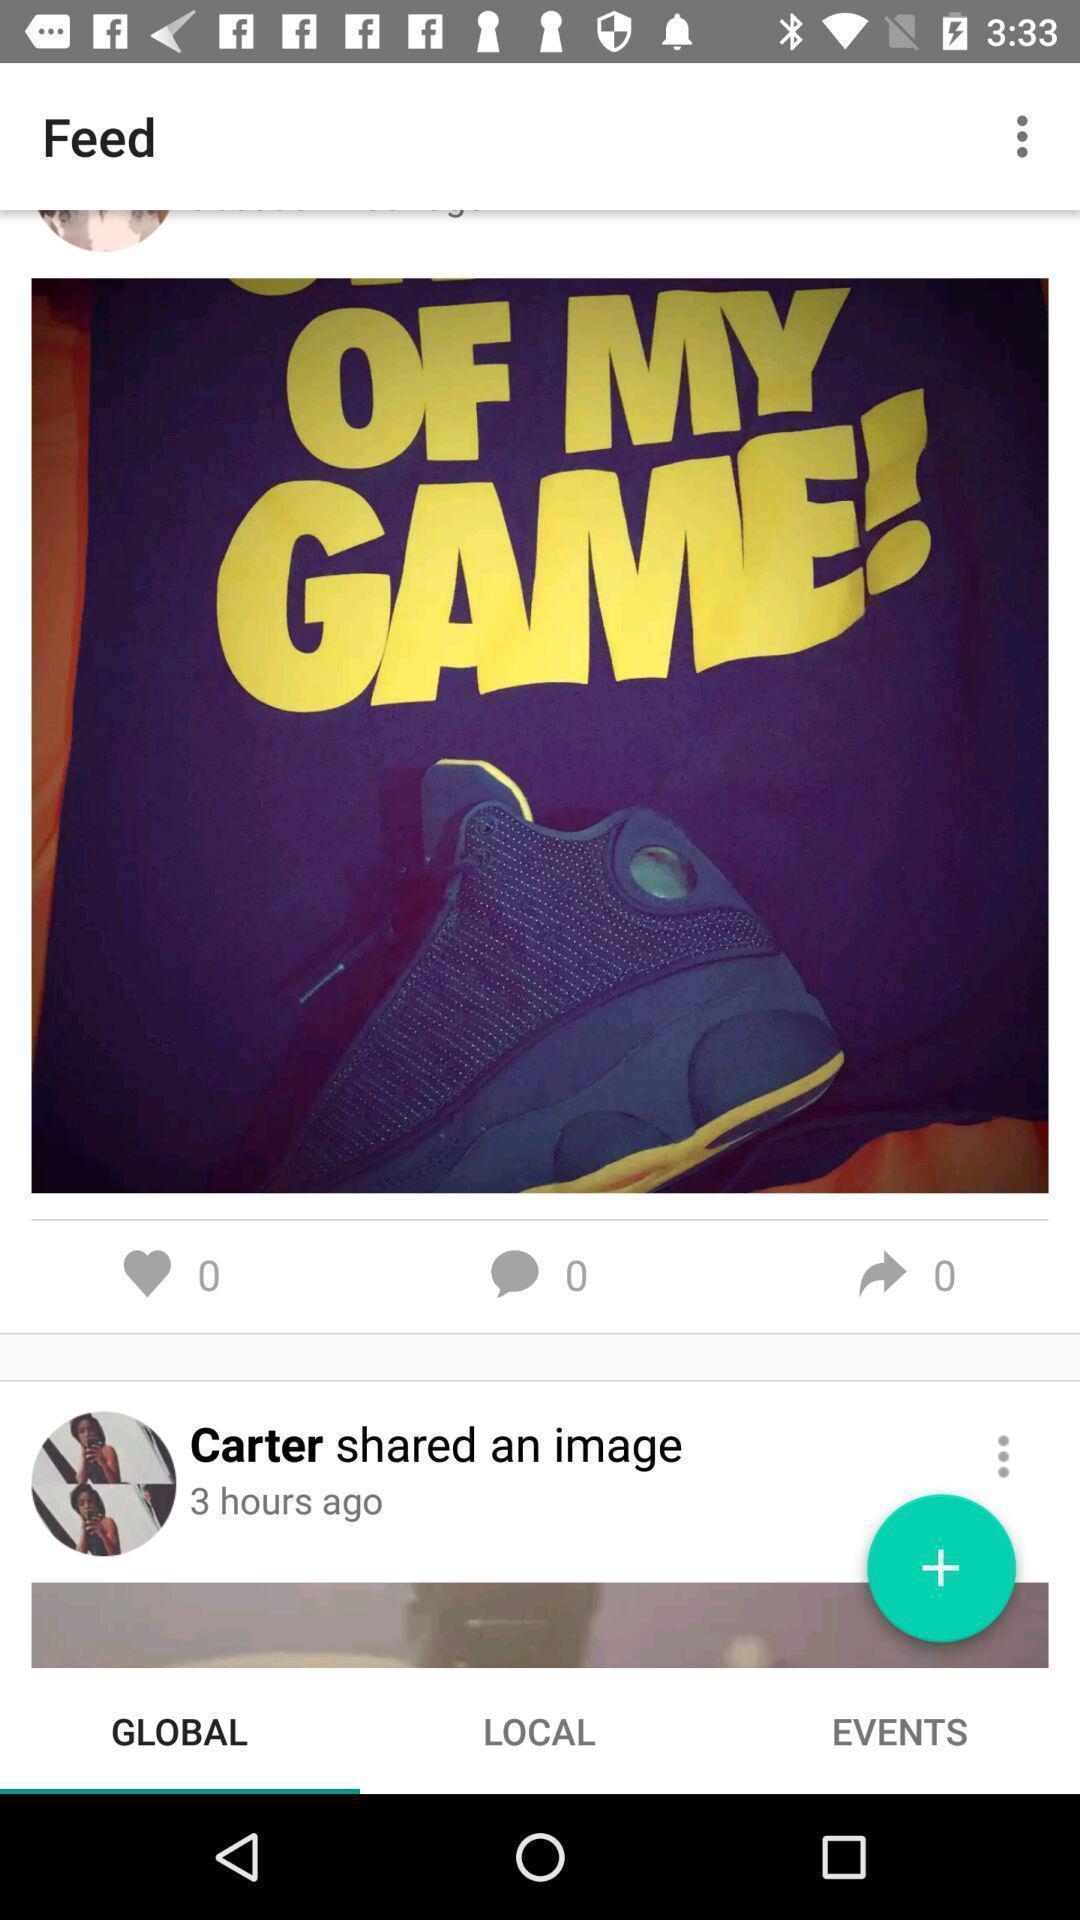Describe the visual elements of this screenshot. Various feed displayed in social media app. 